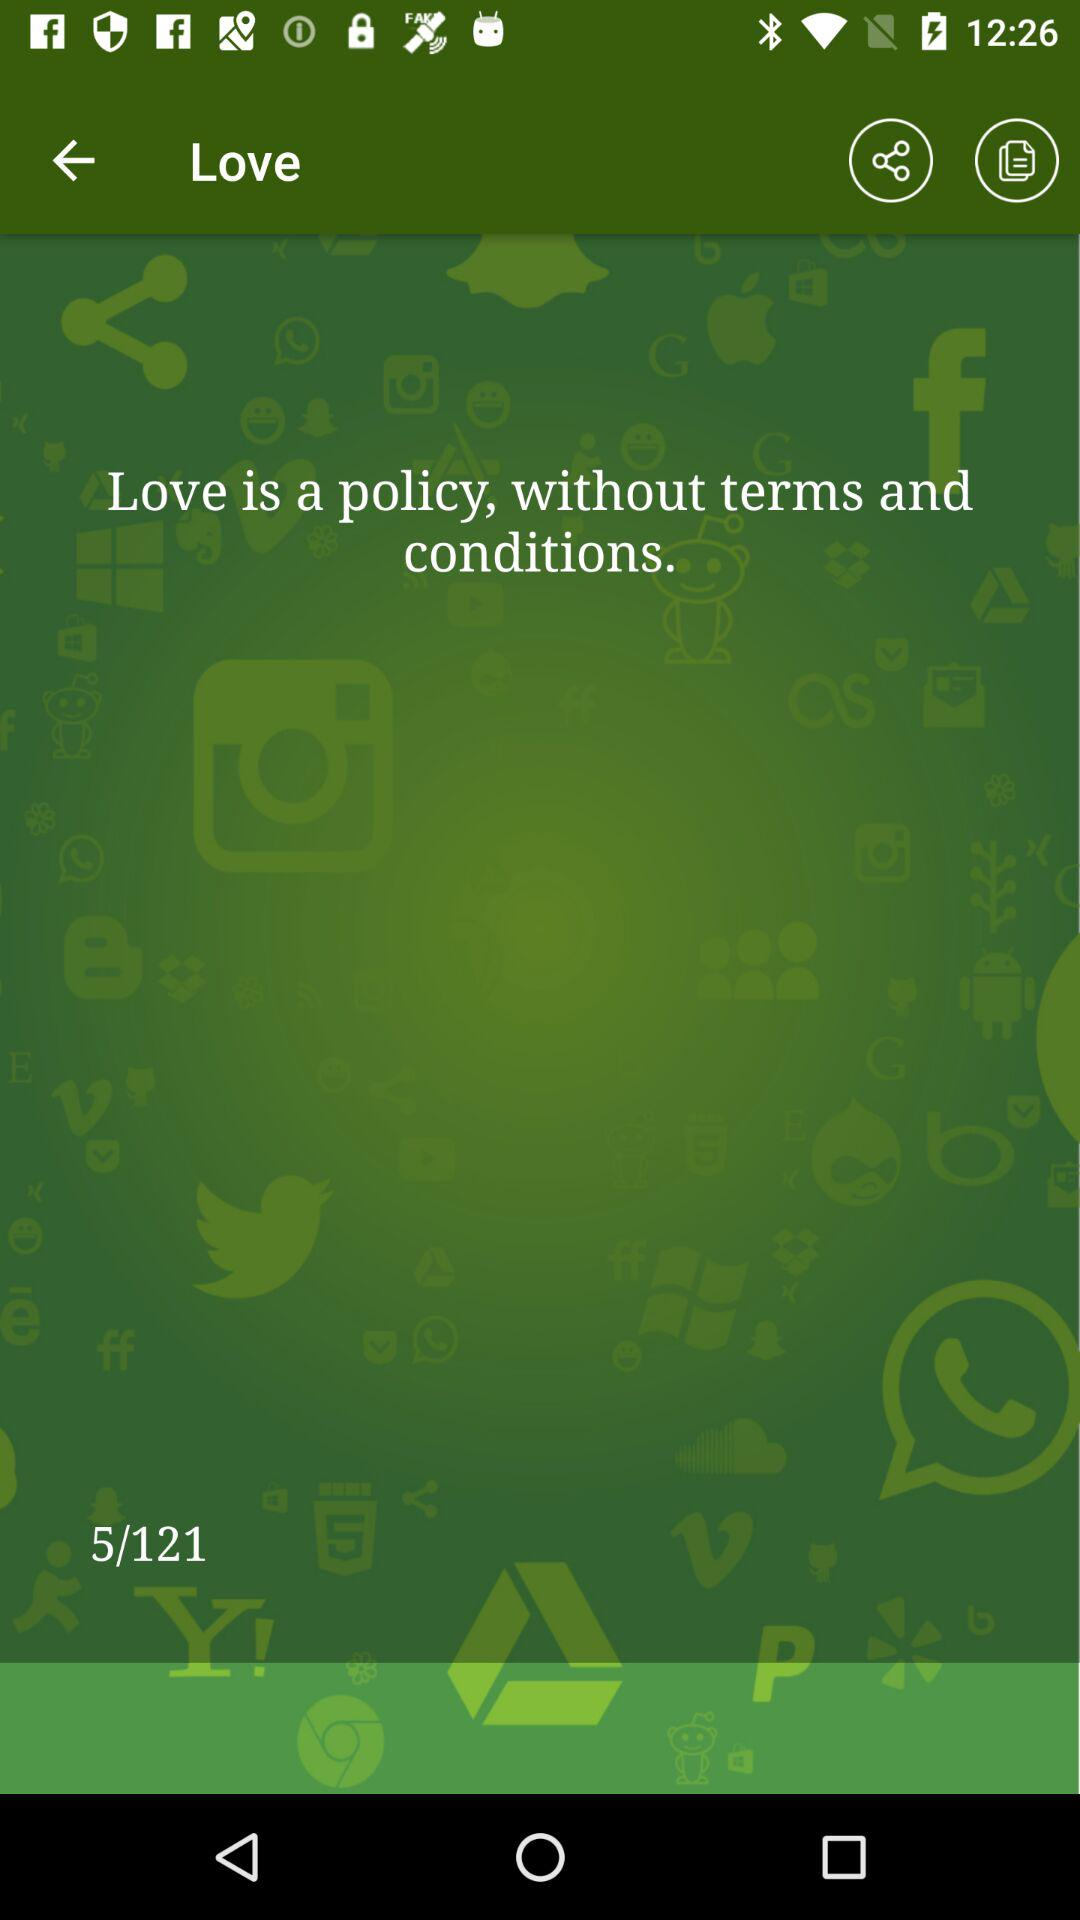What is the total number of pages? The total number of pages is 121. 